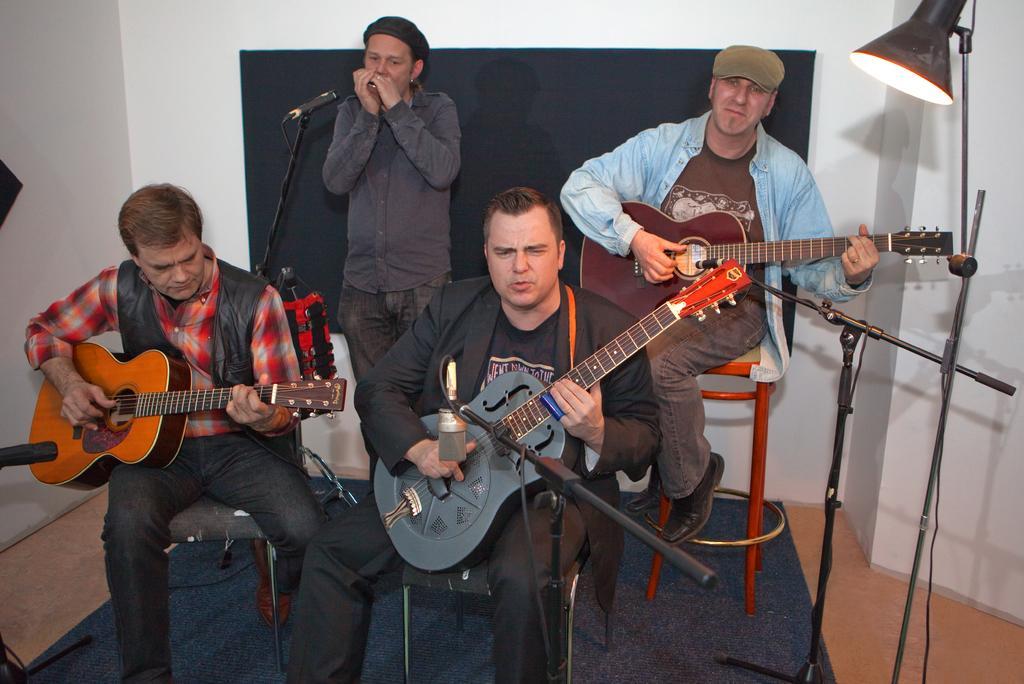In one or two sentences, can you explain what this image depicts? There are 4 people. On the right side we have a person. He's wearing a cap. The other person is standing. They all are playing a guitar. We can see in the background there is light and blackboard. 